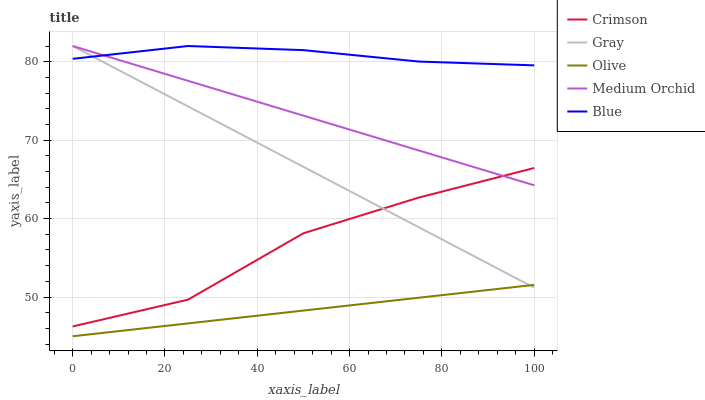Does Gray have the minimum area under the curve?
Answer yes or no. No. Does Gray have the maximum area under the curve?
Answer yes or no. No. Is Gray the smoothest?
Answer yes or no. No. Is Gray the roughest?
Answer yes or no. No. Does Gray have the lowest value?
Answer yes or no. No. Does Olive have the highest value?
Answer yes or no. No. Is Olive less than Crimson?
Answer yes or no. Yes. Is Blue greater than Olive?
Answer yes or no. Yes. Does Olive intersect Crimson?
Answer yes or no. No. 